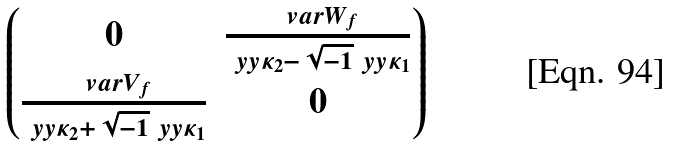<formula> <loc_0><loc_0><loc_500><loc_500>\begin{pmatrix} 0 & \frac { \ v a r W _ { f } } { \ y y { \kappa } _ { 2 } - \sqrt { - 1 } \ y y { \kappa } _ { 1 } } \\ \frac { \ v a r V _ { f } } { \ y y { \kappa } _ { 2 } + \sqrt { - 1 } \ y y { \kappa } _ { 1 } } & 0 \end{pmatrix}</formula> 